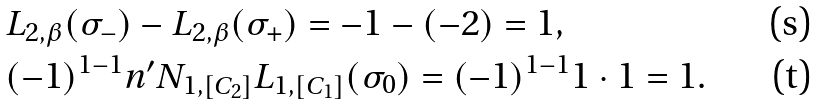Convert formula to latex. <formula><loc_0><loc_0><loc_500><loc_500>& L _ { 2 , \beta } ( \sigma _ { - } ) - L _ { 2 , \beta } ( \sigma _ { + } ) = - 1 - ( - 2 ) = 1 , \\ & ( - 1 ) ^ { 1 - 1 } n ^ { \prime } N _ { 1 , [ C _ { 2 } ] } L _ { 1 , [ C _ { 1 } ] } ( \sigma _ { 0 } ) = ( - 1 ) ^ { 1 - 1 } 1 \cdot 1 = 1 .</formula> 